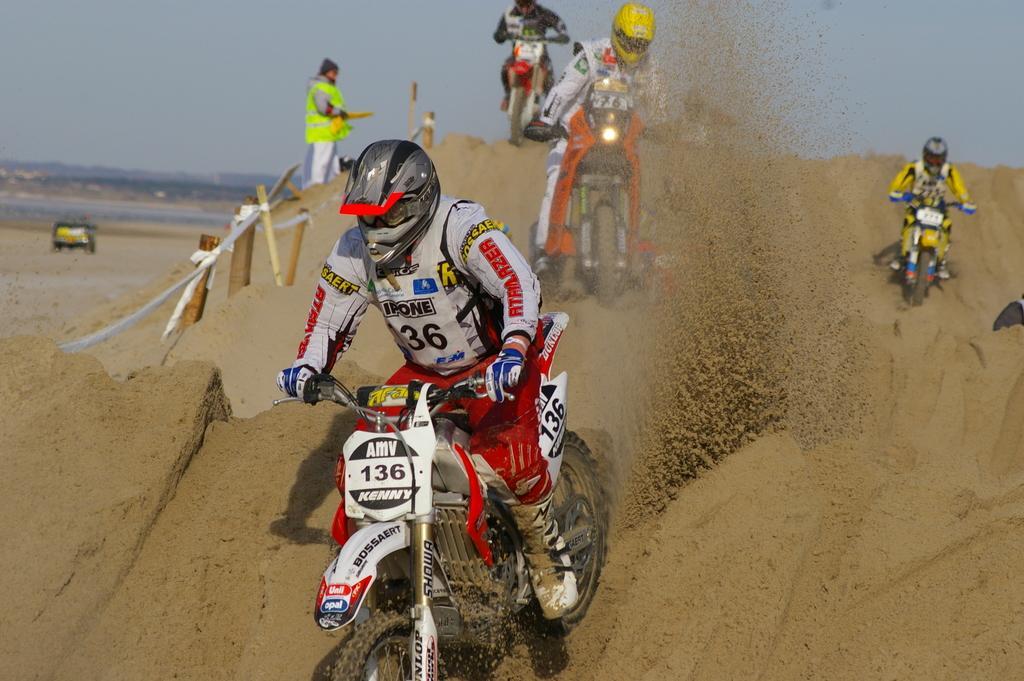Please provide a concise description of this image. In this picture there some dirt bikers riding in the sand, wearing a white and red color costume dress with helmet. Behind we can see a man wearing green color jacket is standing in giving the directions. 